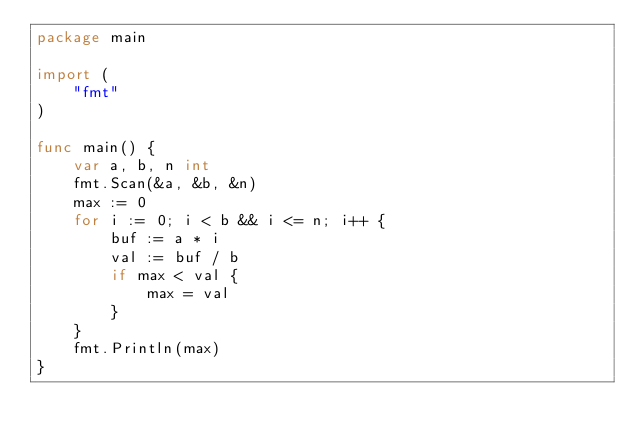Convert code to text. <code><loc_0><loc_0><loc_500><loc_500><_Go_>package main

import (
	"fmt"
)

func main() {
	var a, b, n int
	fmt.Scan(&a, &b, &n)
	max := 0
	for i := 0; i < b && i <= n; i++ {
		buf := a * i
		val := buf / b
		if max < val {
			max = val
		}
	}
	fmt.Println(max)
}
</code> 